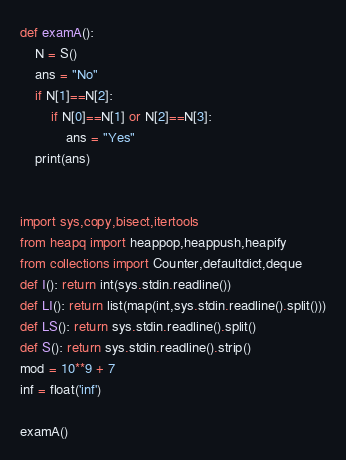<code> <loc_0><loc_0><loc_500><loc_500><_Python_>def examA():
    N = S()
    ans = "No"
    if N[1]==N[2]:
        if N[0]==N[1] or N[2]==N[3]:
            ans = "Yes"
    print(ans)


import sys,copy,bisect,itertools
from heapq import heappop,heappush,heapify
from collections import Counter,defaultdict,deque
def I(): return int(sys.stdin.readline())
def LI(): return list(map(int,sys.stdin.readline().split()))
def LS(): return sys.stdin.readline().split()
def S(): return sys.stdin.readline().strip()
mod = 10**9 + 7
inf = float('inf')

examA()</code> 